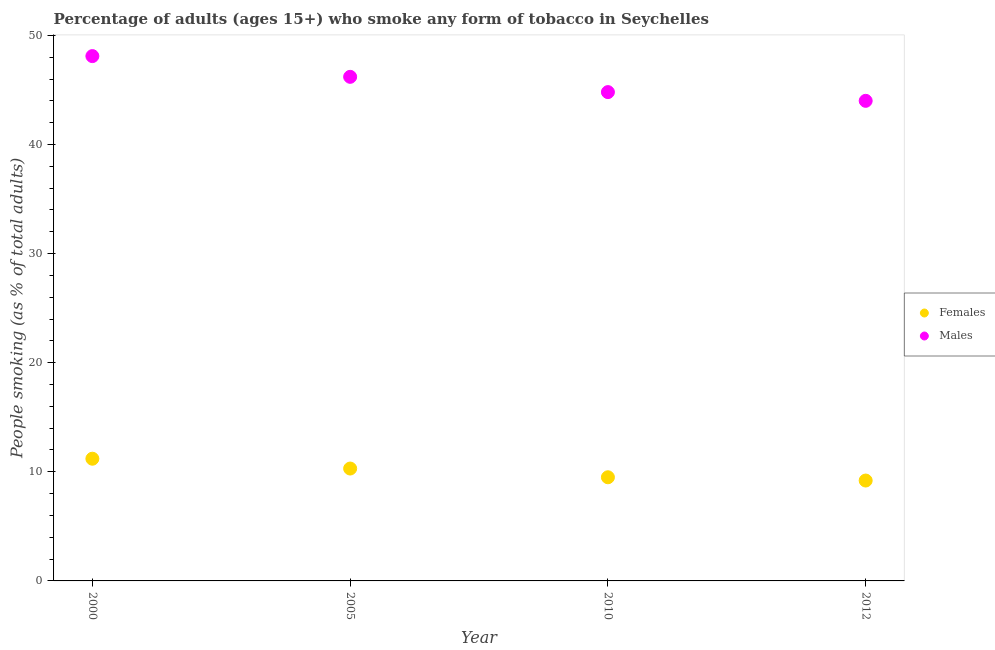What is the percentage of males who smoke in 2000?
Make the answer very short. 48.1. Across all years, what is the maximum percentage of males who smoke?
Ensure brevity in your answer.  48.1. In which year was the percentage of males who smoke minimum?
Offer a very short reply. 2012. What is the total percentage of females who smoke in the graph?
Offer a terse response. 40.2. What is the difference between the percentage of females who smoke in 2000 and that in 2005?
Make the answer very short. 0.9. What is the difference between the percentage of females who smoke in 2010 and the percentage of males who smoke in 2005?
Offer a very short reply. -36.7. What is the average percentage of females who smoke per year?
Ensure brevity in your answer.  10.05. In the year 2005, what is the difference between the percentage of males who smoke and percentage of females who smoke?
Keep it short and to the point. 35.9. What is the ratio of the percentage of males who smoke in 2010 to that in 2012?
Ensure brevity in your answer.  1.02. Is the percentage of males who smoke in 2000 less than that in 2012?
Your answer should be compact. No. What is the difference between the highest and the second highest percentage of males who smoke?
Ensure brevity in your answer.  1.9. Is the percentage of females who smoke strictly greater than the percentage of males who smoke over the years?
Make the answer very short. No. Is the percentage of males who smoke strictly less than the percentage of females who smoke over the years?
Ensure brevity in your answer.  No. What is the difference between two consecutive major ticks on the Y-axis?
Give a very brief answer. 10. Does the graph contain any zero values?
Your answer should be compact. No. Does the graph contain grids?
Keep it short and to the point. No. Where does the legend appear in the graph?
Offer a very short reply. Center right. How many legend labels are there?
Your answer should be very brief. 2. What is the title of the graph?
Your answer should be very brief. Percentage of adults (ages 15+) who smoke any form of tobacco in Seychelles. Does "Age 15+" appear as one of the legend labels in the graph?
Your response must be concise. No. What is the label or title of the Y-axis?
Keep it short and to the point. People smoking (as % of total adults). What is the People smoking (as % of total adults) in Females in 2000?
Provide a succinct answer. 11.2. What is the People smoking (as % of total adults) of Males in 2000?
Make the answer very short. 48.1. What is the People smoking (as % of total adults) of Males in 2005?
Your answer should be compact. 46.2. What is the People smoking (as % of total adults) of Females in 2010?
Make the answer very short. 9.5. What is the People smoking (as % of total adults) in Males in 2010?
Provide a succinct answer. 44.8. What is the People smoking (as % of total adults) in Females in 2012?
Keep it short and to the point. 9.2. Across all years, what is the maximum People smoking (as % of total adults) of Males?
Offer a terse response. 48.1. Across all years, what is the minimum People smoking (as % of total adults) in Females?
Your answer should be very brief. 9.2. Across all years, what is the minimum People smoking (as % of total adults) in Males?
Give a very brief answer. 44. What is the total People smoking (as % of total adults) of Females in the graph?
Your response must be concise. 40.2. What is the total People smoking (as % of total adults) in Males in the graph?
Give a very brief answer. 183.1. What is the difference between the People smoking (as % of total adults) of Females in 2000 and that in 2005?
Offer a very short reply. 0.9. What is the difference between the People smoking (as % of total adults) in Males in 2000 and that in 2010?
Your answer should be very brief. 3.3. What is the difference between the People smoking (as % of total adults) in Males in 2000 and that in 2012?
Provide a succinct answer. 4.1. What is the difference between the People smoking (as % of total adults) of Females in 2005 and that in 2010?
Make the answer very short. 0.8. What is the difference between the People smoking (as % of total adults) of Males in 2005 and that in 2010?
Offer a very short reply. 1.4. What is the difference between the People smoking (as % of total adults) of Females in 2010 and that in 2012?
Your answer should be compact. 0.3. What is the difference between the People smoking (as % of total adults) of Females in 2000 and the People smoking (as % of total adults) of Males in 2005?
Make the answer very short. -35. What is the difference between the People smoking (as % of total adults) in Females in 2000 and the People smoking (as % of total adults) in Males in 2010?
Make the answer very short. -33.6. What is the difference between the People smoking (as % of total adults) in Females in 2000 and the People smoking (as % of total adults) in Males in 2012?
Offer a terse response. -32.8. What is the difference between the People smoking (as % of total adults) of Females in 2005 and the People smoking (as % of total adults) of Males in 2010?
Ensure brevity in your answer.  -34.5. What is the difference between the People smoking (as % of total adults) of Females in 2005 and the People smoking (as % of total adults) of Males in 2012?
Keep it short and to the point. -33.7. What is the difference between the People smoking (as % of total adults) in Females in 2010 and the People smoking (as % of total adults) in Males in 2012?
Ensure brevity in your answer.  -34.5. What is the average People smoking (as % of total adults) of Females per year?
Provide a short and direct response. 10.05. What is the average People smoking (as % of total adults) of Males per year?
Offer a terse response. 45.77. In the year 2000, what is the difference between the People smoking (as % of total adults) of Females and People smoking (as % of total adults) of Males?
Offer a very short reply. -36.9. In the year 2005, what is the difference between the People smoking (as % of total adults) in Females and People smoking (as % of total adults) in Males?
Keep it short and to the point. -35.9. In the year 2010, what is the difference between the People smoking (as % of total adults) in Females and People smoking (as % of total adults) in Males?
Provide a succinct answer. -35.3. In the year 2012, what is the difference between the People smoking (as % of total adults) in Females and People smoking (as % of total adults) in Males?
Your answer should be very brief. -34.8. What is the ratio of the People smoking (as % of total adults) in Females in 2000 to that in 2005?
Your answer should be compact. 1.09. What is the ratio of the People smoking (as % of total adults) of Males in 2000 to that in 2005?
Keep it short and to the point. 1.04. What is the ratio of the People smoking (as % of total adults) of Females in 2000 to that in 2010?
Your answer should be very brief. 1.18. What is the ratio of the People smoking (as % of total adults) in Males in 2000 to that in 2010?
Give a very brief answer. 1.07. What is the ratio of the People smoking (as % of total adults) of Females in 2000 to that in 2012?
Your answer should be very brief. 1.22. What is the ratio of the People smoking (as % of total adults) of Males in 2000 to that in 2012?
Give a very brief answer. 1.09. What is the ratio of the People smoking (as % of total adults) in Females in 2005 to that in 2010?
Give a very brief answer. 1.08. What is the ratio of the People smoking (as % of total adults) in Males in 2005 to that in 2010?
Ensure brevity in your answer.  1.03. What is the ratio of the People smoking (as % of total adults) of Females in 2005 to that in 2012?
Provide a succinct answer. 1.12. What is the ratio of the People smoking (as % of total adults) of Females in 2010 to that in 2012?
Give a very brief answer. 1.03. What is the ratio of the People smoking (as % of total adults) in Males in 2010 to that in 2012?
Provide a short and direct response. 1.02. What is the difference between the highest and the lowest People smoking (as % of total adults) in Males?
Offer a terse response. 4.1. 